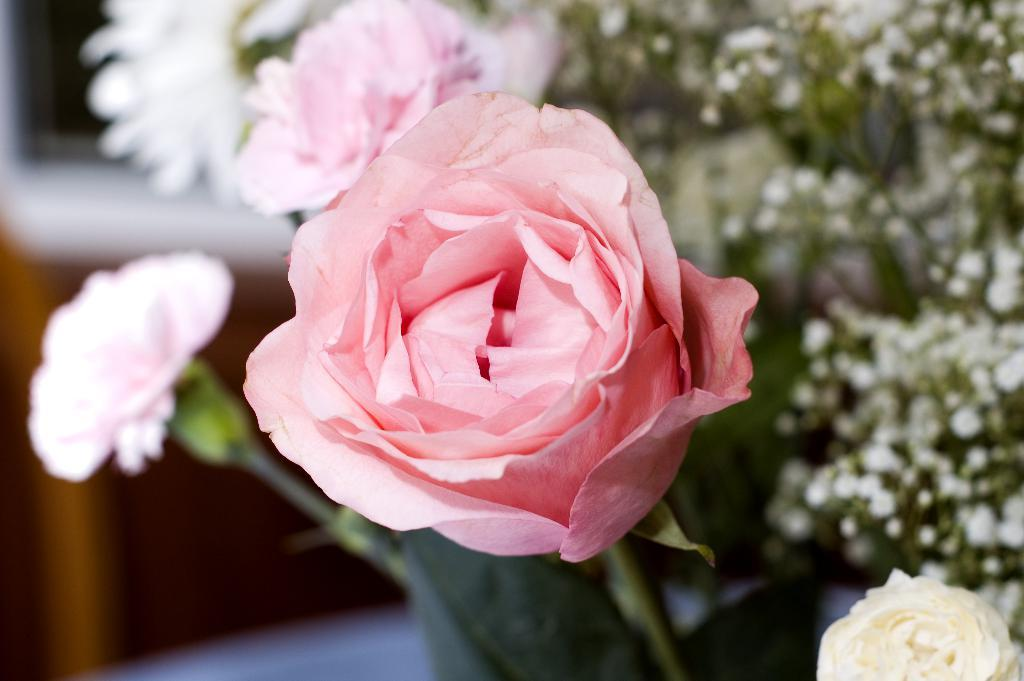What type of living organisms can be seen in the image? There are flowers in the image. Can you describe the plant with small flowers on the right side of the image? Yes, there is a plant with small flowers on the right side of the image. What can be observed about the background of the image? The background of the image is blurred. What else can be seen in the background of the image besides the blurred area? There are objects visible in the background of the image. What type of soda is being poured into the bowl of soup in the image? There is no soda or soup present in the image; it features flowers and a plant with small flowers. How many tomatoes can be seen growing on the plant in the image? There are no tomatoes present in the image; it features flowers and a plant with small flowers. 